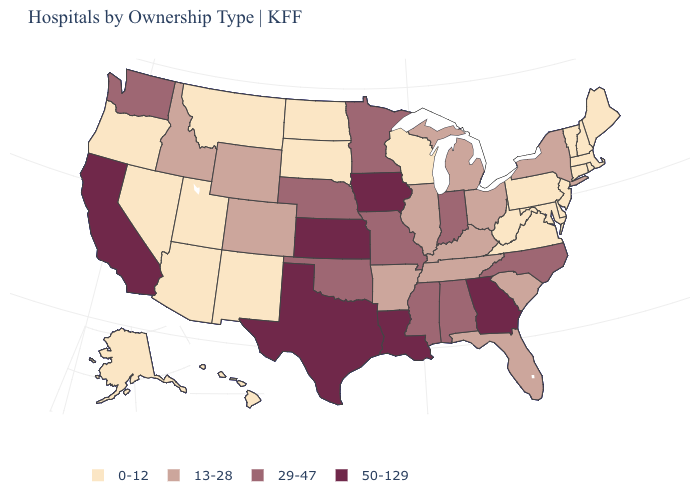How many symbols are there in the legend?
Give a very brief answer. 4. How many symbols are there in the legend?
Concise answer only. 4. What is the lowest value in states that border Rhode Island?
Give a very brief answer. 0-12. How many symbols are there in the legend?
Write a very short answer. 4. What is the highest value in the USA?
Quick response, please. 50-129. What is the value of California?
Short answer required. 50-129. How many symbols are there in the legend?
Concise answer only. 4. Among the states that border New Jersey , does New York have the highest value?
Give a very brief answer. Yes. Name the states that have a value in the range 13-28?
Be succinct. Arkansas, Colorado, Florida, Idaho, Illinois, Kentucky, Michigan, New York, Ohio, South Carolina, Tennessee, Wyoming. Does Ohio have the lowest value in the USA?
Answer briefly. No. What is the lowest value in the MidWest?
Write a very short answer. 0-12. What is the lowest value in states that border New Jersey?
Be succinct. 0-12. Does Illinois have the highest value in the MidWest?
Write a very short answer. No. What is the value of New Mexico?
Quick response, please. 0-12. Among the states that border Ohio , does Kentucky have the highest value?
Short answer required. No. 